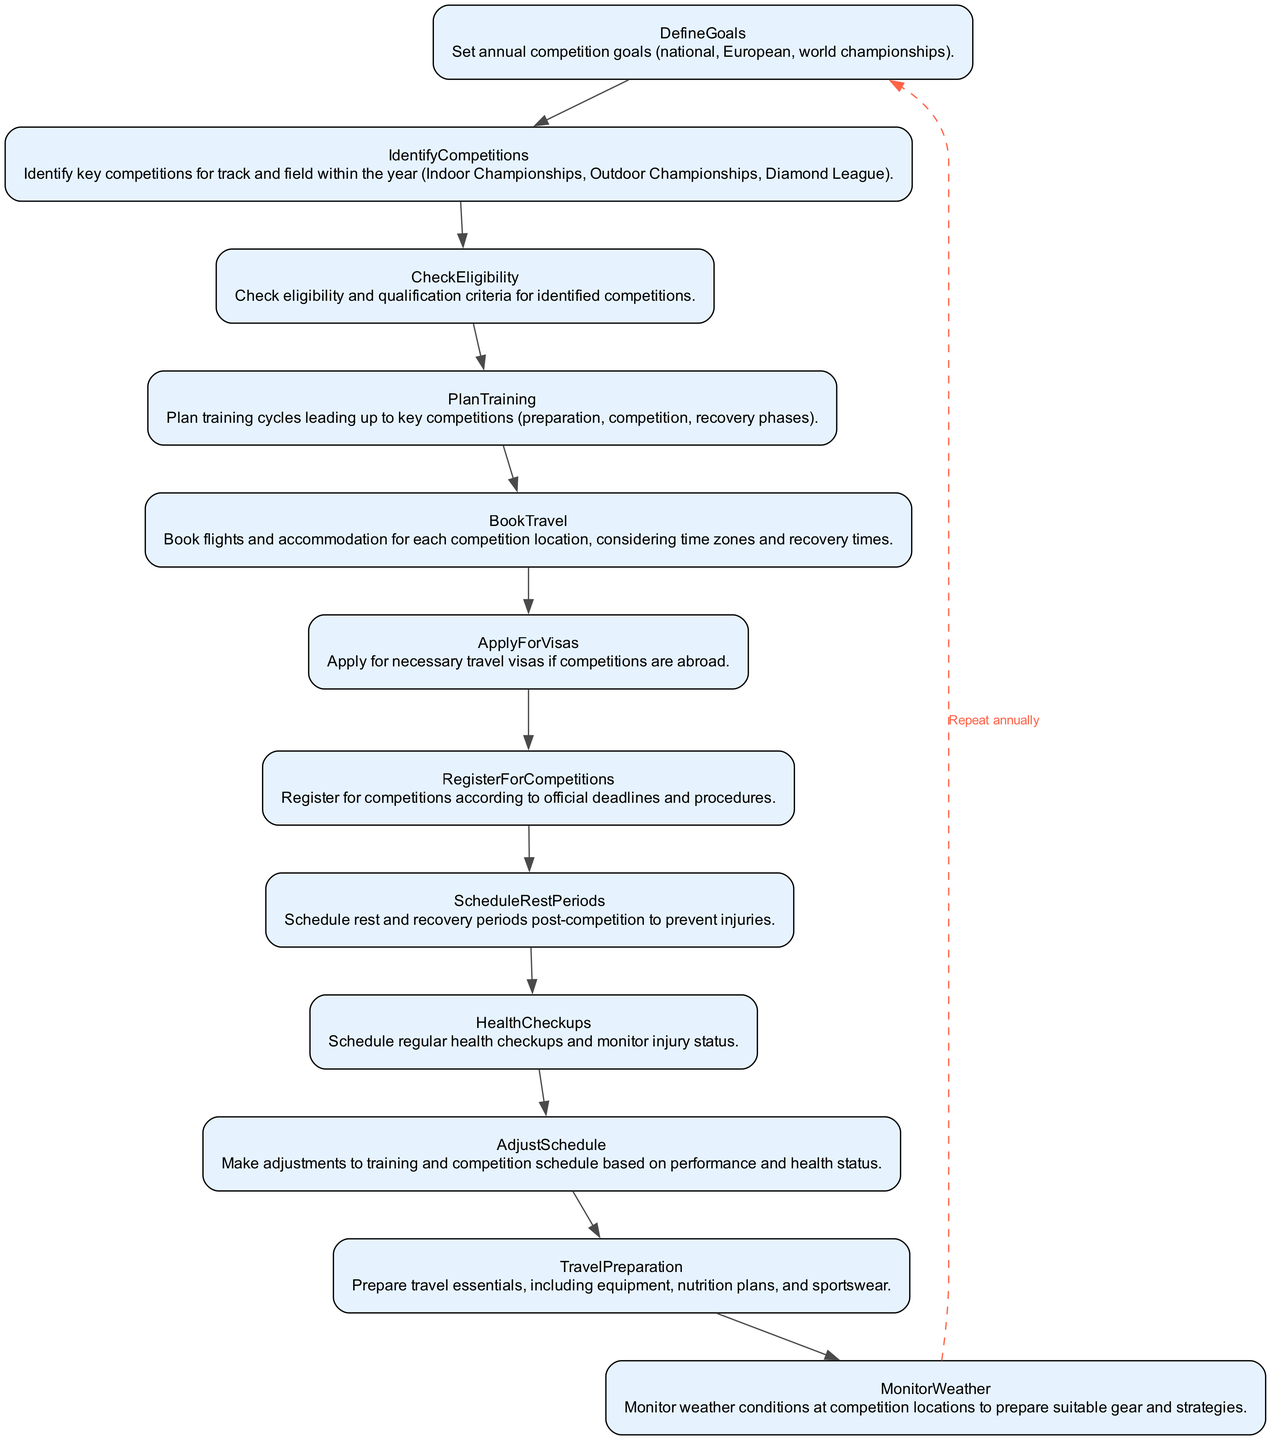What is the first step in the diagram? The diagram starts with the first element, which is "DefineGoals", where annual competition goals are set.
Answer: DefineGoals How many main actions are outlined in the diagram? There are a total of 12 main actions/nodes represented in the diagram, detailing the travel and competition management process.
Answer: 12 What is the last action before the cycle back to the first node? The last action before returning to "DefineGoals" is "MonitorWeather", which entails checking the weather conditions at competition locations.
Answer: MonitorWeather Which node checks the eligibility criteria? The node titled "CheckEligibility" is responsible for verifying eligibility and qualification criteria for competitions, following the identification of competitions.
Answer: CheckEligibility What follows "ScheduleRestPeriods" in the flow? In the flowchart, "ScheduleRestPeriods" is followed by "HealthCheckups", which focuses on regular health assessments and injury monitoring.
Answer: HealthCheckups Which action involves booking flights and accommodation? The action related to booking flights and accommodation is called "BookTravel", which occurs after planning training and checking eligibility.
Answer: BookTravel What is the purpose of the "AdjustSchedule" node? The "AdjustSchedule" node is meant to revise training and competition schedules according to performance and health status to ensure optimal preparation.
Answer: Revise training and competition schedules What is meant by the dashed edge at the end of the flow? The dashed edge from "MonitorWeather" to "DefineGoals" indicates repeating the process annually, suggesting that this is a recurring cycle of planning and execution.
Answer: Repeat annually What is the prerequisite for "RegisterForCompetitions"? Before registering for competitions, one must first complete the "CheckEligibility" action, ensuring that all necessary criteria are met.
Answer: CheckEligibility 